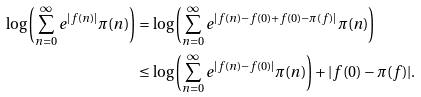<formula> <loc_0><loc_0><loc_500><loc_500>\log \left ( \sum _ { n = 0 } ^ { \infty } e ^ { | f ( n ) | } \pi ( n ) \right ) & = \log \left ( \sum _ { n = 0 } ^ { \infty } e ^ { | f ( n ) - f ( 0 ) + f ( 0 ) - \pi ( f ) | } \pi ( n ) \right ) \\ & \leq \log \left ( \sum _ { n = 0 } ^ { \infty } e ^ { | f ( n ) - f ( 0 ) | } \pi ( n ) \right ) + | f ( 0 ) - \pi ( f ) | .</formula> 